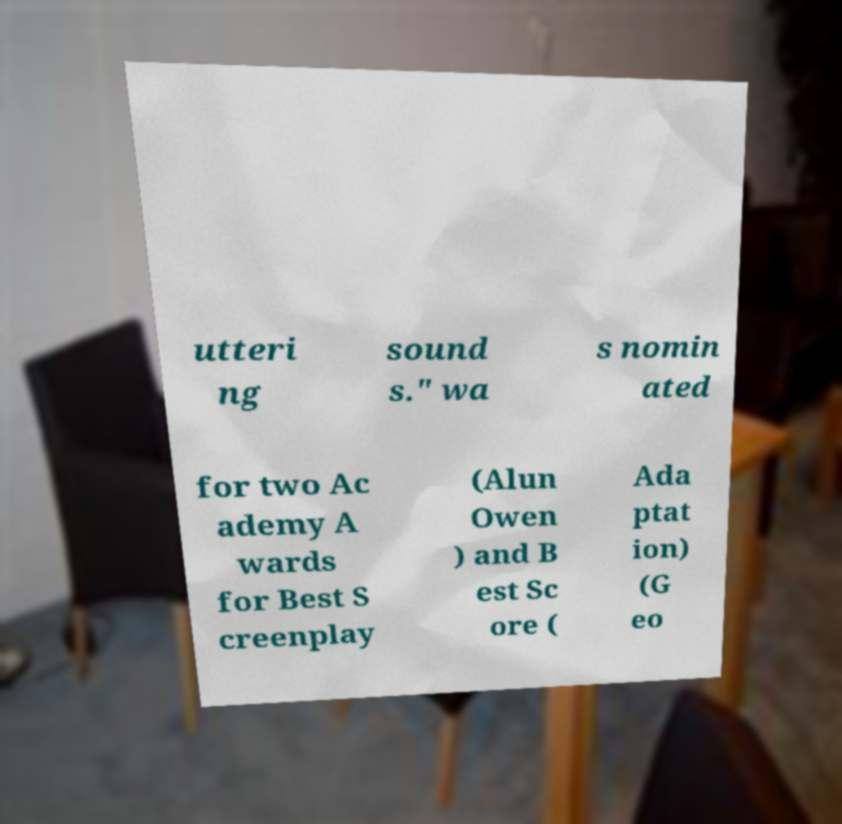Could you assist in decoding the text presented in this image and type it out clearly? utteri ng sound s." wa s nomin ated for two Ac ademy A wards for Best S creenplay (Alun Owen ) and B est Sc ore ( Ada ptat ion) (G eo 